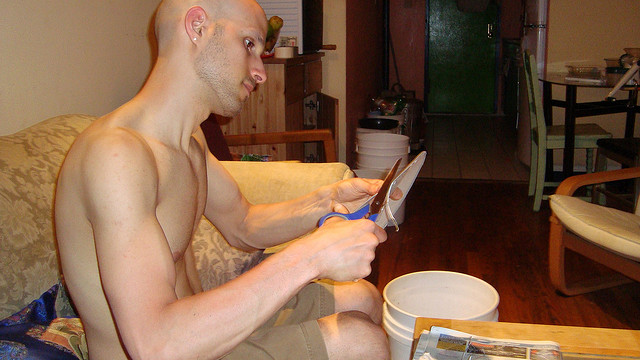<image>What kind of decor is on the arm of the couch? It is ambiguous what kind of decor is on the arm of the couch. It might be a pillow or there might be none. What kind of decor is on the arm of the couch? I am not sure what kind of decor is on the arm of the couch. It can be seen 'paint', 'modern', 'blanket', 'none', 'solid color', 'pillow' or 'floral'. 